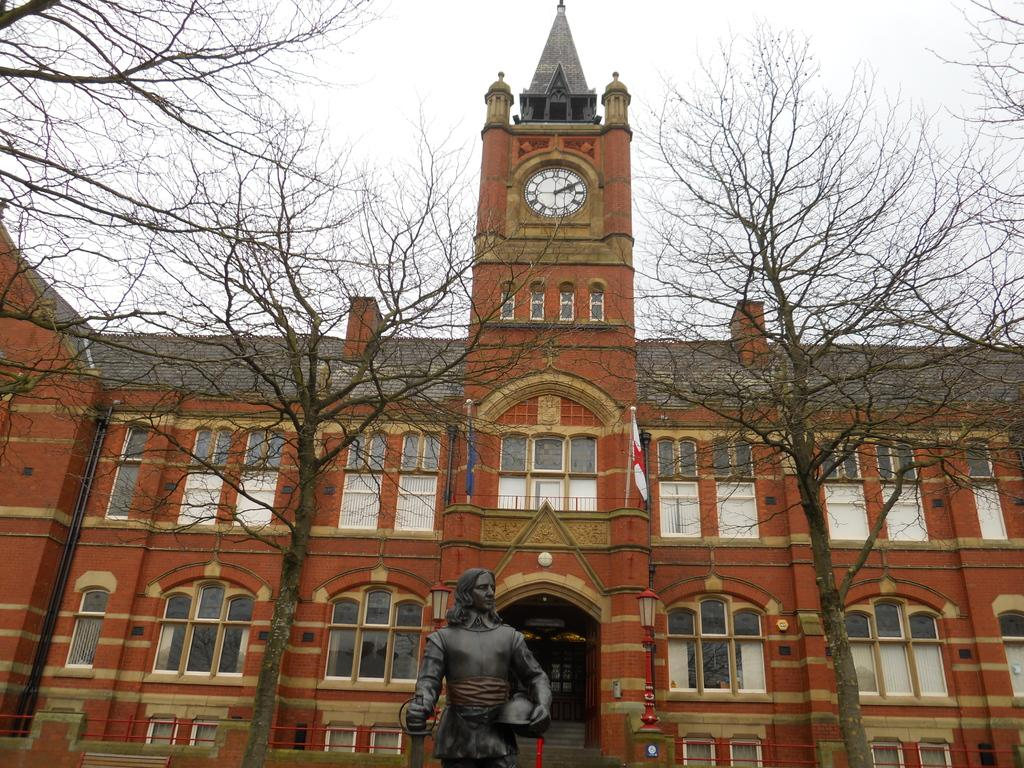What type of structure is present in the image? There is a building in the image. What feature of the building is mentioned in the facts? The building has windows. What other objects can be seen in the image? There is a wall clock, a light pole, flags on the wall, a statue, and trees in the image. What part of the natural environment is visible in the image? The sky is visible in the image. What type of celery is growing near the statue in the image? There is no celery present in the image; it is a statue surrounded by trees and other objects. 